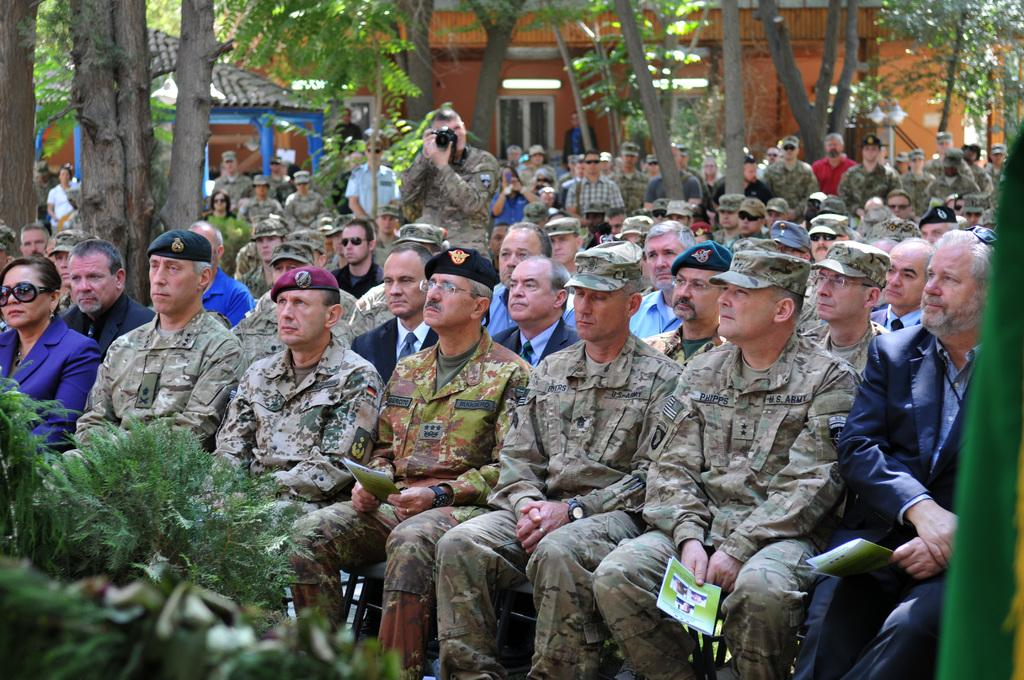What can be seen in the foreground of the image? There are persons sitting on chairs in the foreground of the image. What is visible in the background of the image? There are huts, buildings, and trees in the background of the image. Where are the plants located in the image? The plants are in the left bottom corner of the image. What type of verse can be heard being recited by the birds in the image? There are no birds present in the image, so it is not possible to hear any verses being recited by them. How many eggs are visible in the image? There are no eggs visible in the image. 